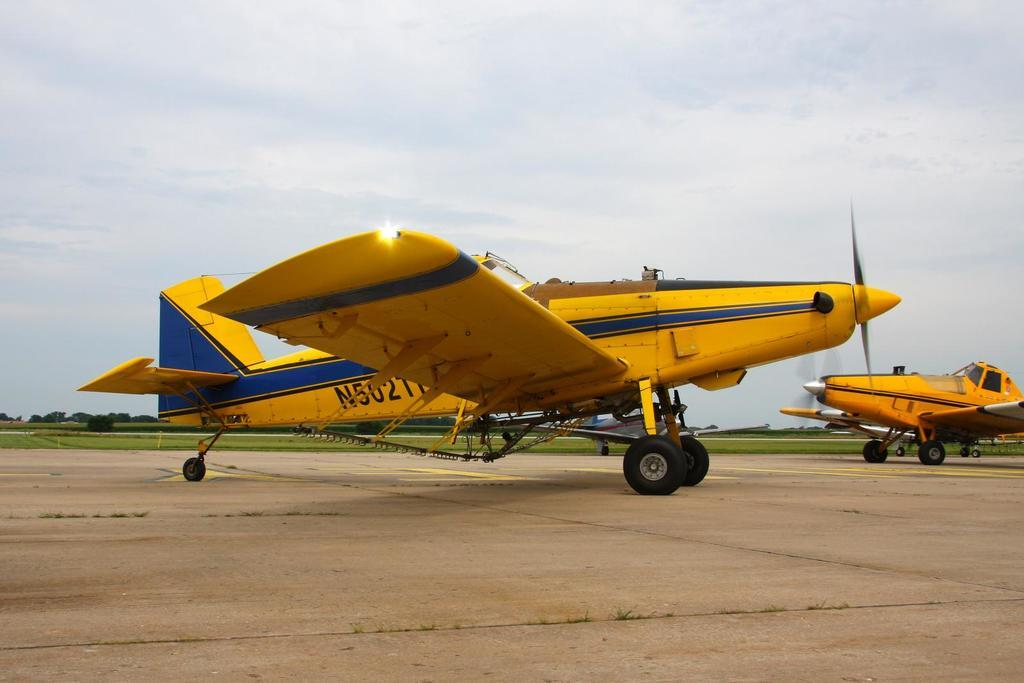<image>
Write a terse but informative summary of the picture. A small yellow and blue plane which reads N5027 on the side 